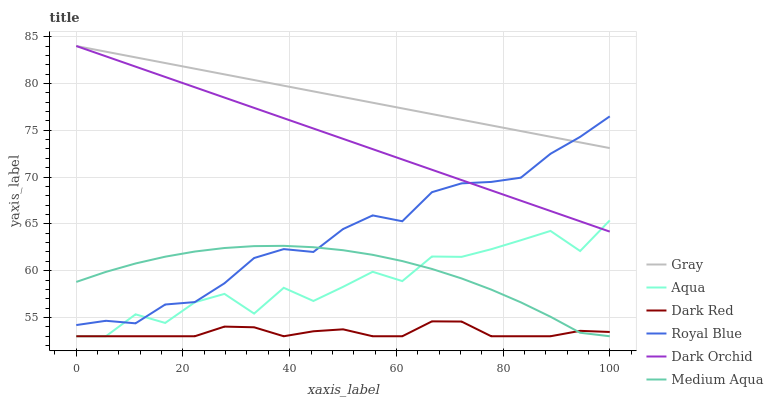Does Aqua have the minimum area under the curve?
Answer yes or no. No. Does Aqua have the maximum area under the curve?
Answer yes or no. No. Is Dark Red the smoothest?
Answer yes or no. No. Is Dark Red the roughest?
Answer yes or no. No. Does Dark Orchid have the lowest value?
Answer yes or no. No. Does Aqua have the highest value?
Answer yes or no. No. Is Dark Red less than Dark Orchid?
Answer yes or no. Yes. Is Gray greater than Dark Red?
Answer yes or no. Yes. Does Dark Red intersect Dark Orchid?
Answer yes or no. No. 